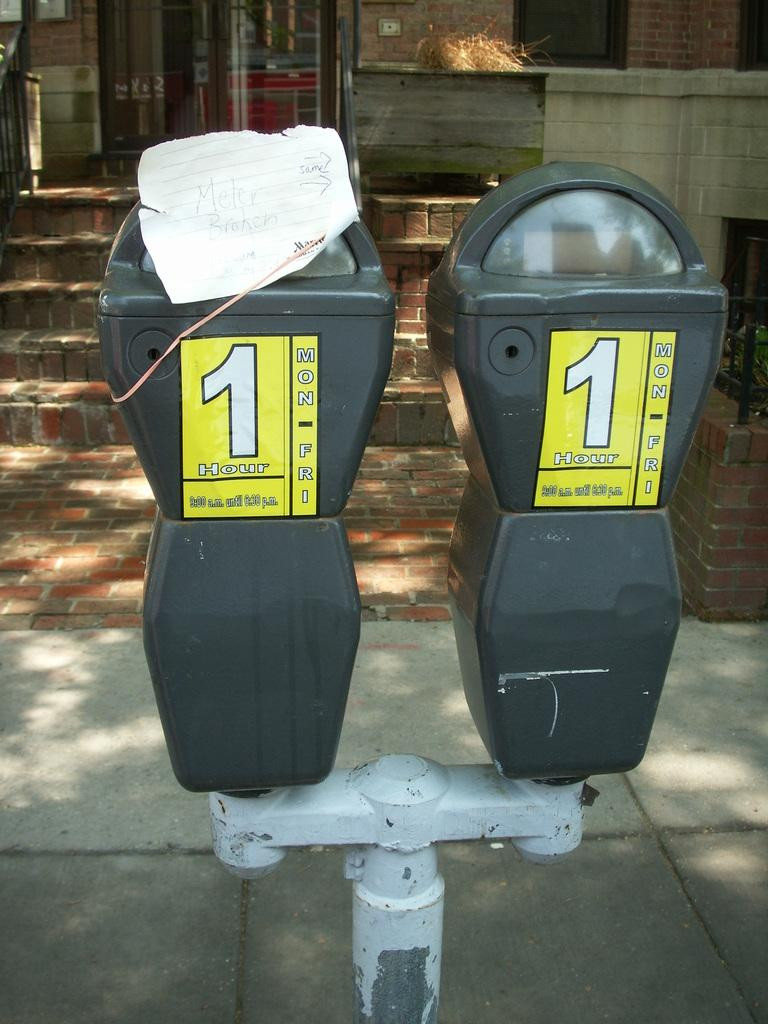Provide a one-sentence caption for the provided image. Two toll meters with yellow stickers that read 1 hour only. 